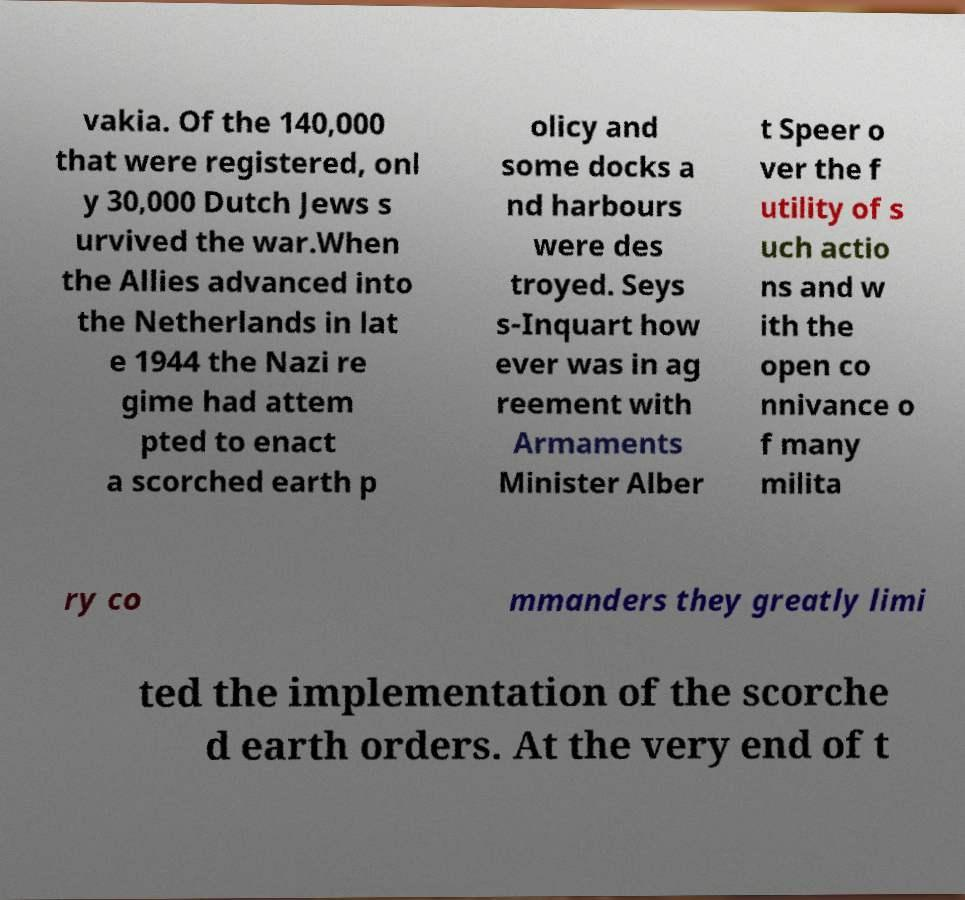Can you accurately transcribe the text from the provided image for me? vakia. Of the 140,000 that were registered, onl y 30,000 Dutch Jews s urvived the war.When the Allies advanced into the Netherlands in lat e 1944 the Nazi re gime had attem pted to enact a scorched earth p olicy and some docks a nd harbours were des troyed. Seys s-Inquart how ever was in ag reement with Armaments Minister Alber t Speer o ver the f utility of s uch actio ns and w ith the open co nnivance o f many milita ry co mmanders they greatly limi ted the implementation of the scorche d earth orders. At the very end of t 